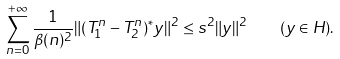Convert formula to latex. <formula><loc_0><loc_0><loc_500><loc_500>\sum _ { n = 0 } ^ { + \infty } \frac { 1 } { \beta ( n ) ^ { 2 } } \| ( T _ { 1 } ^ { n } - T _ { 2 } ^ { n } ) ^ { \ast } y \| ^ { 2 } \leq s ^ { 2 } \| y \| ^ { 2 } \quad ( y \in H ) .</formula> 